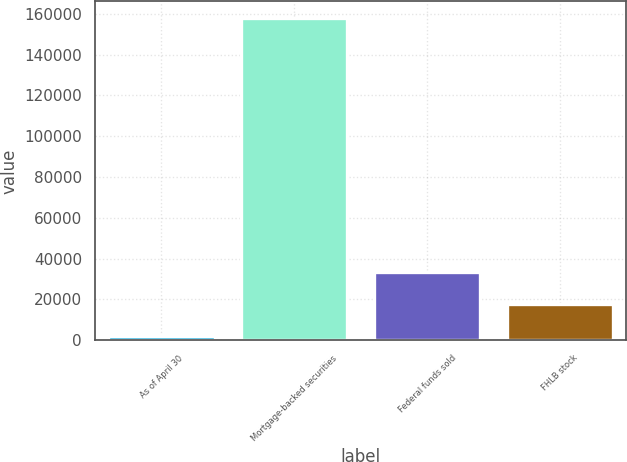<chart> <loc_0><loc_0><loc_500><loc_500><bar_chart><fcel>As of April 30<fcel>Mortgage-backed securities<fcel>Federal funds sold<fcel>FHLB stock<nl><fcel>2011<fcel>158177<fcel>33244.2<fcel>17627.6<nl></chart> 